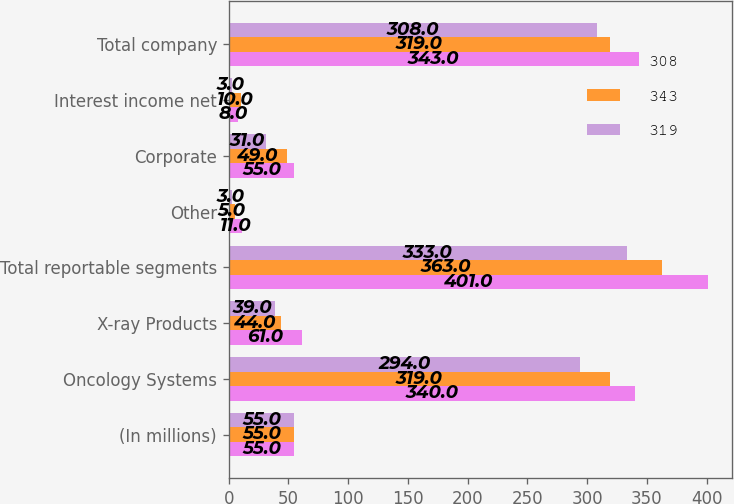Convert chart. <chart><loc_0><loc_0><loc_500><loc_500><stacked_bar_chart><ecel><fcel>(In millions)<fcel>Oncology Systems<fcel>X-ray Products<fcel>Total reportable segments<fcel>Other<fcel>Corporate<fcel>Interest income net<fcel>Total company<nl><fcel>308<fcel>55<fcel>340<fcel>61<fcel>401<fcel>11<fcel>55<fcel>8<fcel>343<nl><fcel>343<fcel>55<fcel>319<fcel>44<fcel>363<fcel>5<fcel>49<fcel>10<fcel>319<nl><fcel>319<fcel>55<fcel>294<fcel>39<fcel>333<fcel>3<fcel>31<fcel>3<fcel>308<nl></chart> 